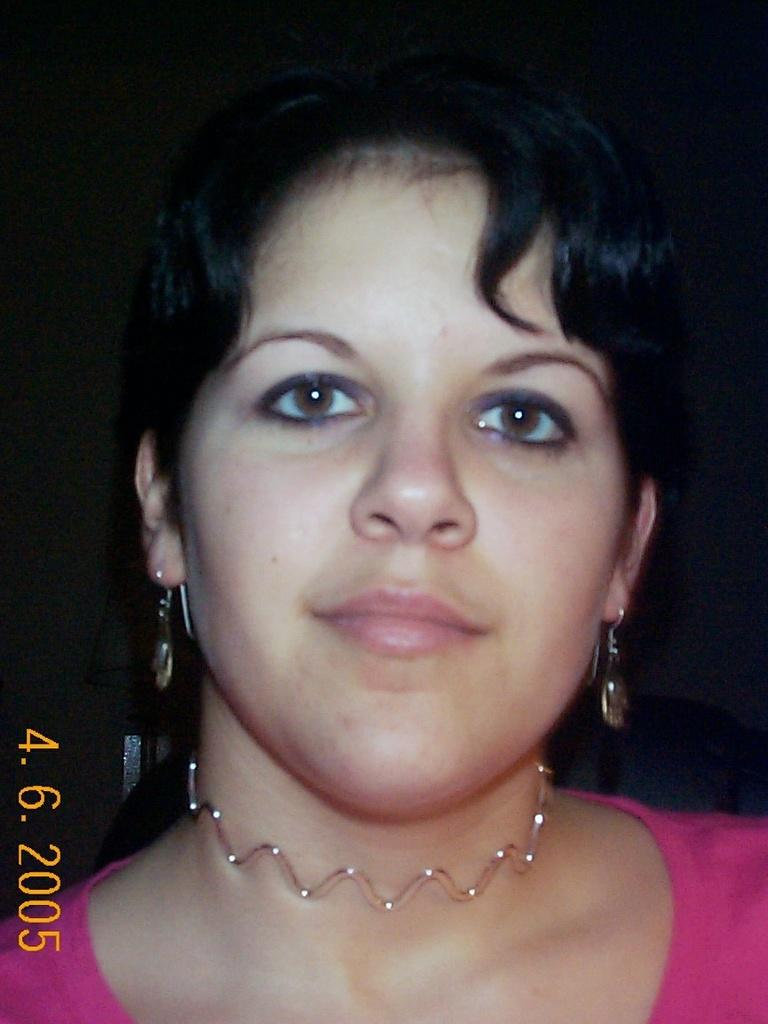What is the main subject of the image? There is a woman's face in the image. Is there any additional information provided in the image? Yes, there is a date, month, and year at the bottom left of the image. Can you describe the background of the image? The background of the image is dark. What type of plough is being used in the image? There is no plough present in the image; it features a woman's face. How does the woman's stomach appear in the image? The image only shows the woman's face, so her stomach is not visible. 